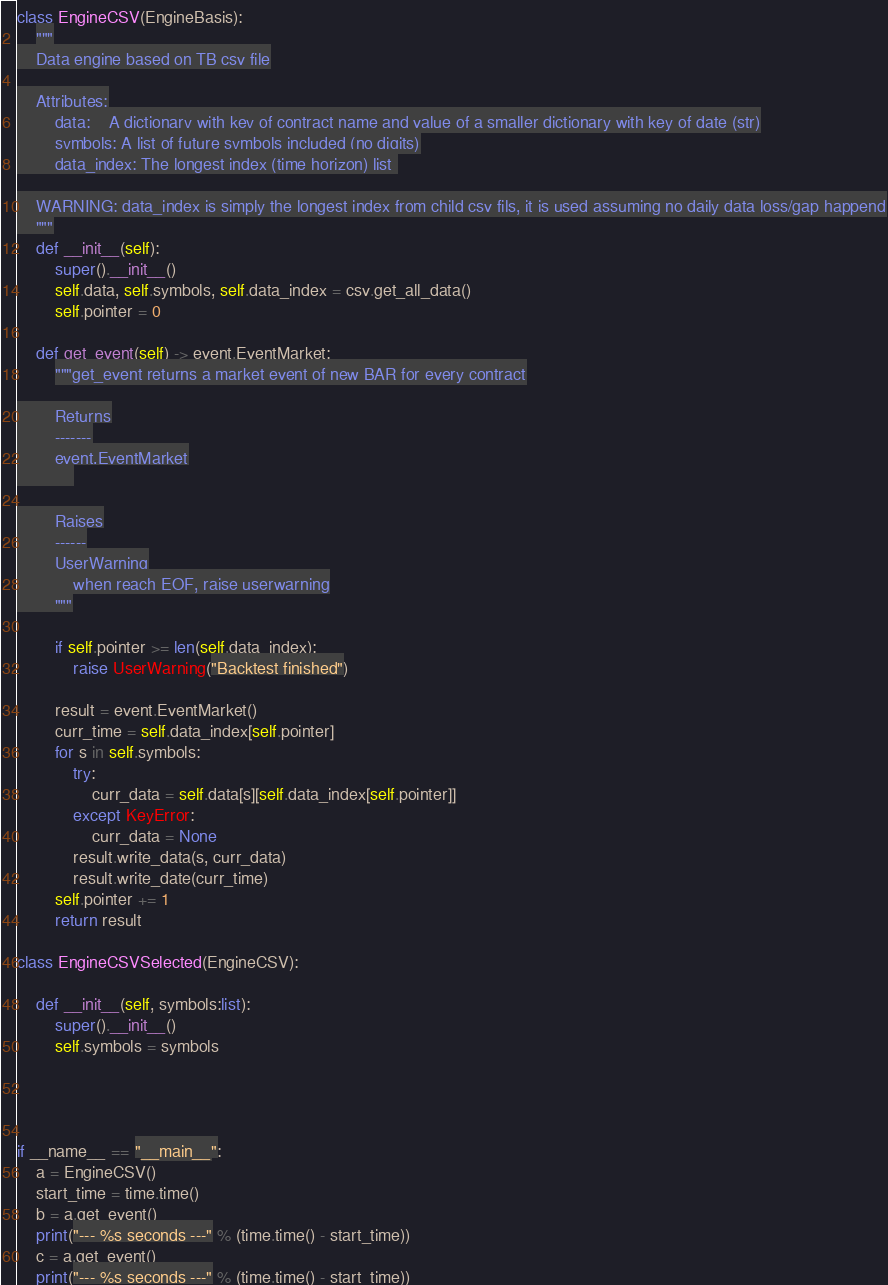<code> <loc_0><loc_0><loc_500><loc_500><_Python_>class EngineCSV(EngineBasis):
    """
    Data engine based on TB csv file

    Attributes:
        data:    A dictionary with key of contract name and value of a smaller dictionary with key of date (str)
        symbols: A list of future symbols included (no digits)
        data_index: The longest index (time horizon) list 

    WARNING: data_index is simply the longest index from child csv fils, it is used assuming no daily data loss/gap happend
    """
    def __init__(self):
        super().__init__()
        self.data, self.symbols, self.data_index = csv.get_all_data()
        self.pointer = 0

    def get_event(self) -> event.EventMarket:
        """get_event returns a market event of new BAR for every contract

        Returns
        -------
        event.EventMarket
            

        Raises
        ------
        UserWarning
            when reach EOF, raise userwarning
        """

        if self.pointer >= len(self.data_index):
            raise UserWarning("Backtest finished")

        result = event.EventMarket()
        curr_time = self.data_index[self.pointer]
        for s in self.symbols:
            try:
                curr_data = self.data[s][self.data_index[self.pointer]]
            except KeyError:
                curr_data = None
            result.write_data(s, curr_data)
            result.write_date(curr_time)
        self.pointer += 1
        return result

class EngineCSVSelected(EngineCSV):

    def __init__(self, symbols:list):
        super().__init__()
        self.symbols = symbols
    



if __name__ == "__main__":
    a = EngineCSV()
    start_time = time.time()
    b = a.get_event()
    print("--- %s seconds ---" % (time.time() - start_time))
    c = a.get_event()
    print("--- %s seconds ---" % (time.time() - start_time))
</code> 